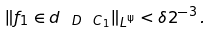<formula> <loc_0><loc_0><loc_500><loc_500>\| f _ { 1 } \in d _ { \ D \ C _ { 1 } } \| _ { L ^ { \Psi } } < \delta 2 ^ { - 3 } \, .</formula> 